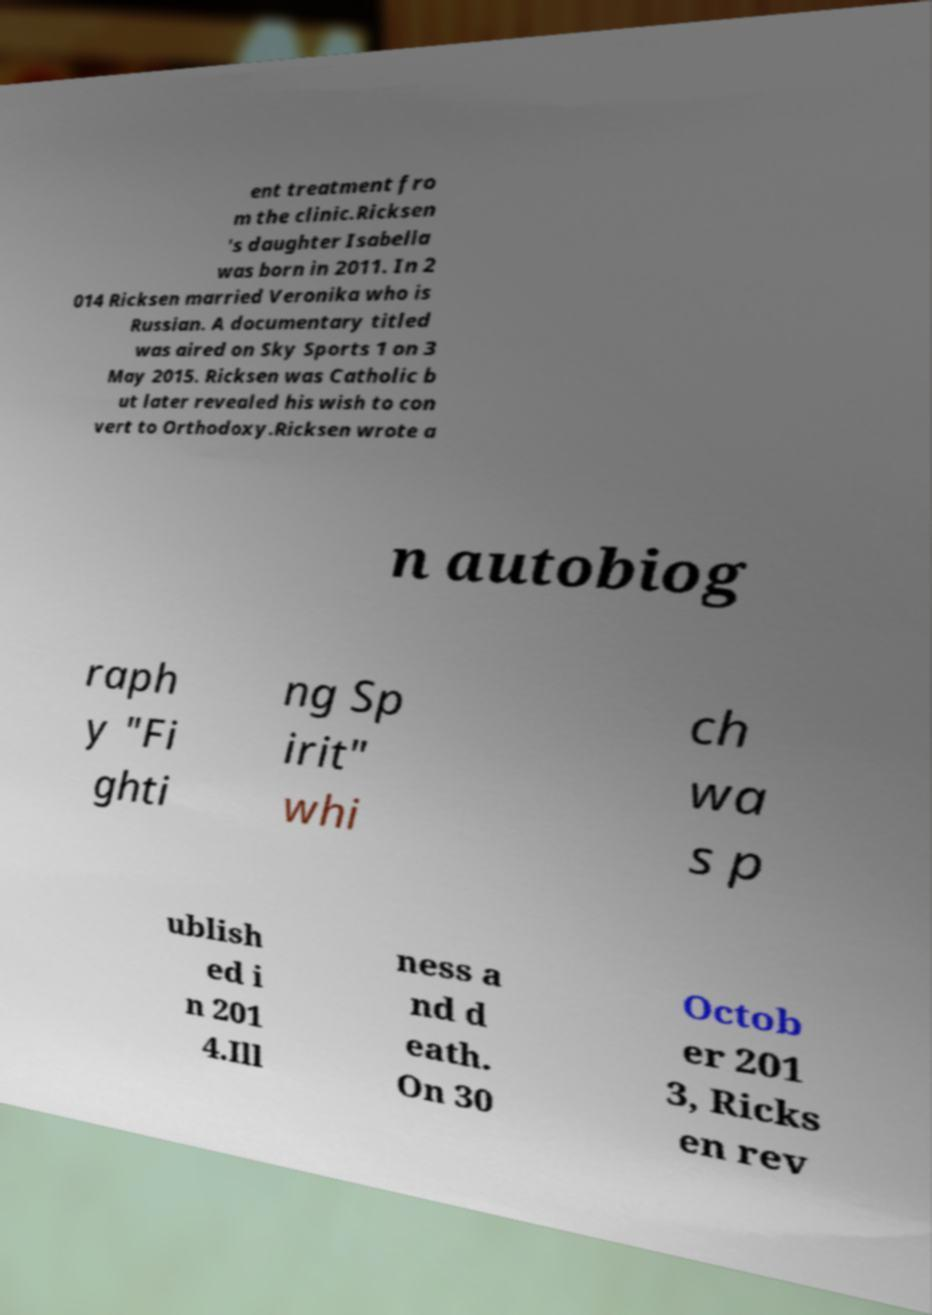There's text embedded in this image that I need extracted. Can you transcribe it verbatim? ent treatment fro m the clinic.Ricksen 's daughter Isabella was born in 2011. In 2 014 Ricksen married Veronika who is Russian. A documentary titled was aired on Sky Sports 1 on 3 May 2015. Ricksen was Catholic b ut later revealed his wish to con vert to Orthodoxy.Ricksen wrote a n autobiog raph y "Fi ghti ng Sp irit" whi ch wa s p ublish ed i n 201 4.Ill ness a nd d eath. On 30 Octob er 201 3, Ricks en rev 